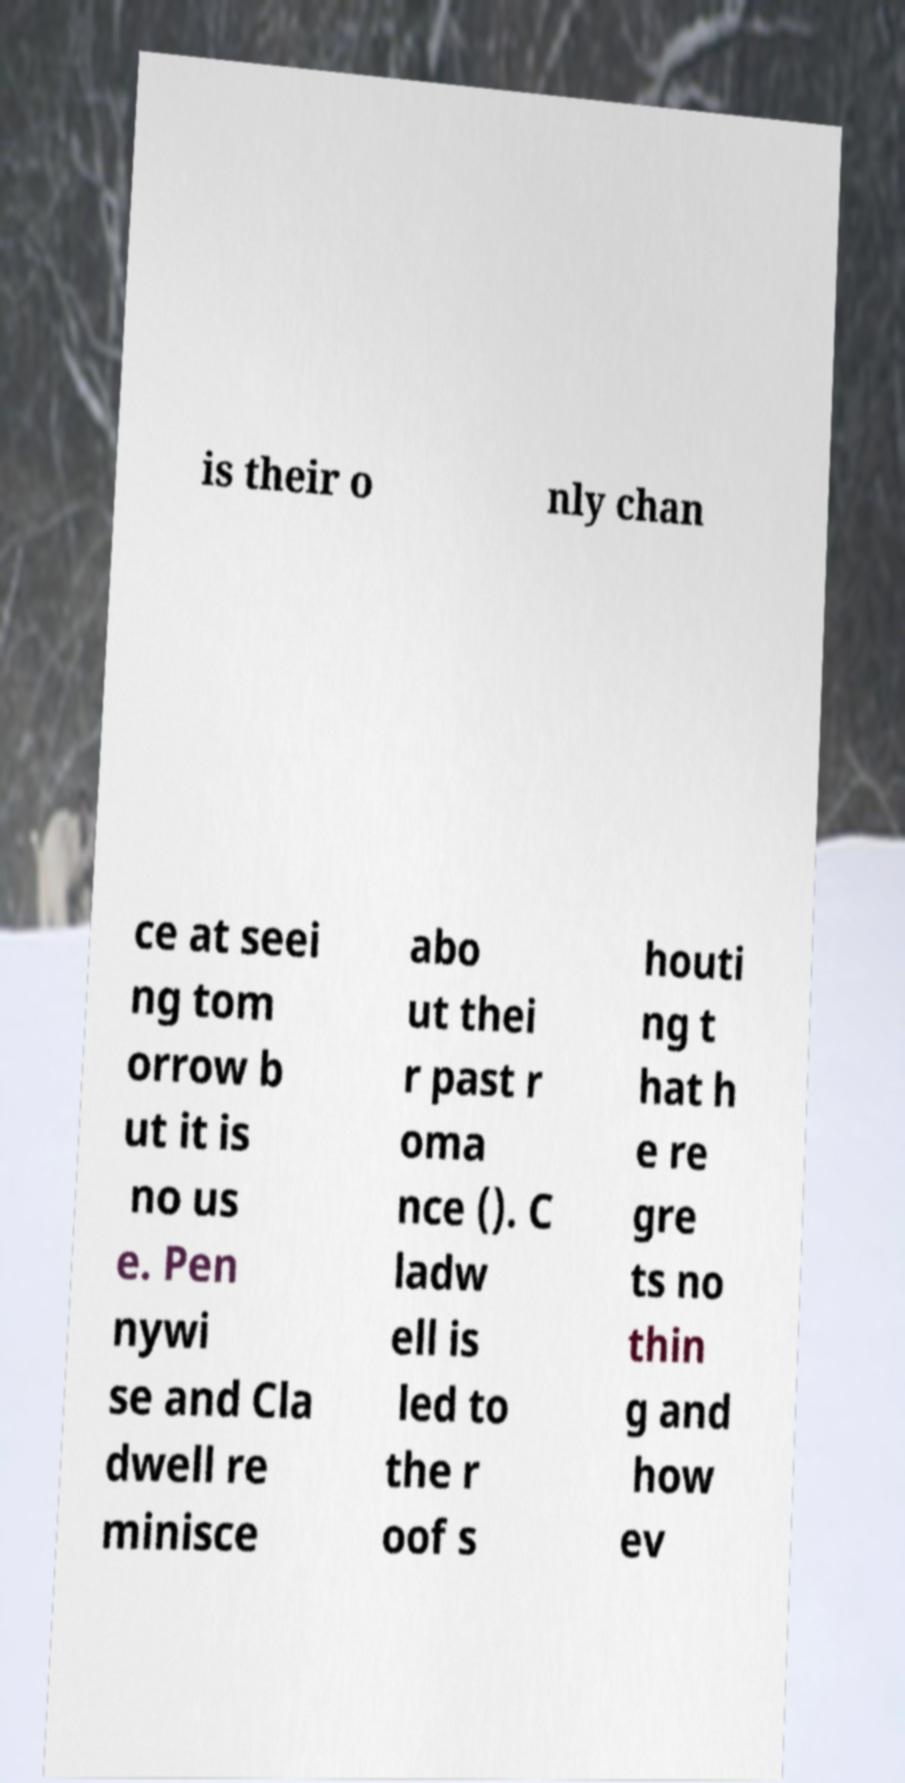What messages or text are displayed in this image? I need them in a readable, typed format. is their o nly chan ce at seei ng tom orrow b ut it is no us e. Pen nywi se and Cla dwell re minisce abo ut thei r past r oma nce (). C ladw ell is led to the r oof s houti ng t hat h e re gre ts no thin g and how ev 